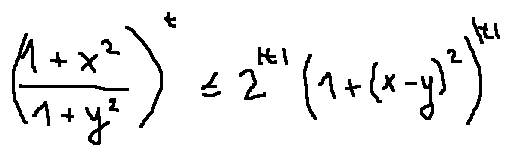<formula> <loc_0><loc_0><loc_500><loc_500>( \frac { 1 + x ^ { 2 } } { 1 + y ^ { 2 } } ) ^ { t } \leq 2 ^ { | t | } ( 1 + ( x - y ) ^ { 2 } ) ^ { | t | }</formula> 